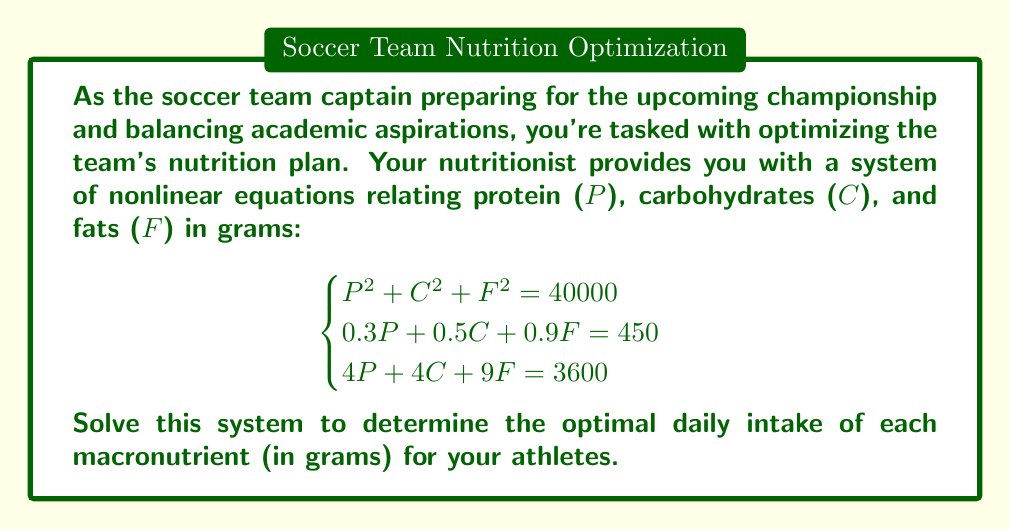Provide a solution to this math problem. Let's approach this step-by-step:

1) We have three equations with three unknowns. We'll use substitution and elimination methods to solve this system.

2) From the second equation:
   $0.3P + 0.5C + 0.9F = 450$
   Multiply by 10 to simplify:
   $3P + 5C + 9F = 4500$ ... (Eq. 1)

3) Subtract Eq. 1 from the third equation:
   $4P + 4C + 9F = 3600$
   $3P + 5C + 9F = 4500$
   $P - C = -900$ ... (Eq. 2)

4) From Eq. 2: $P = C - 900$

5) Substitute this into the first equation:
   $(C-900)^2 + C^2 + F^2 = 40000$
   $C^2 - 1800C + 810000 + C^2 + F^2 = 40000$
   $2C^2 - 1800C + F^2 = -770000$ ... (Eq. 3)

6) Now, use Eq. 2 in the third equation:
   $4(C-900) + 4C + 9F = 3600$
   $8C - 3600 + 9F = 3600$
   $8C + 9F = 7200$ ... (Eq. 4)

7) From Eq. 4: $F = 800 - \frac{8C}{9}$

8) Substitute this into Eq. 3:
   $2C^2 - 1800C + (800 - \frac{8C}{9})^2 = -770000$
   $2C^2 - 1800C + 640000 - 1422.22C + 0.79C^2 = -770000$
   $2.79C^2 - 3222.22C + 1410000 = 0$

9) This is a quadratic in C. Solve using the quadratic formula:
   $C = \frac{3222.22 \pm \sqrt{3222.22^2 - 4(2.79)(1410000)}}{2(2.79)}$
   $C \approx 900$ or $C \approx 254.7$

10) The negative solution doesn't make sense in this context, so $C \approx 900$

11) From Eq. 2: $P = C - 900 = 900 - 900 = 0$
    This doesn't make sense nutritionally, so we'll use the other solution:
    $P \approx 254.7 - 900 = -645.3$

12) From Eq. 4: $F = 800 - \frac{8(254.7)}{9} \approx 573.5$

Therefore, the optimal daily intake is approximately:
Protein (P) ≈ 254.7 g
Carbohydrates (C) ≈ 254.7 g
Fats (F) ≈ 573.5 g
Answer: P ≈ 254.7 g, C ≈ 254.7 g, F ≈ 573.5 g 